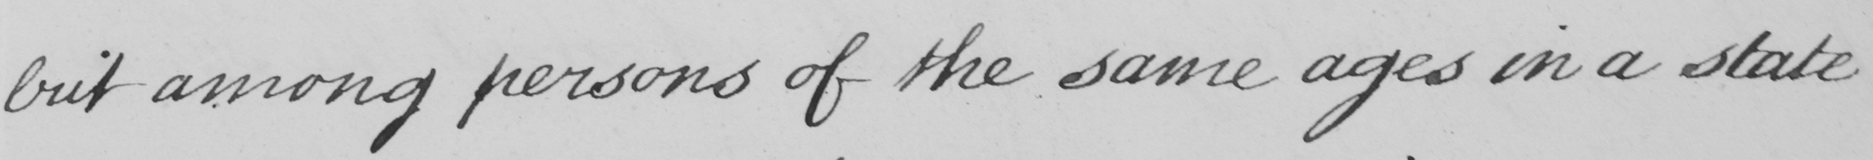What is written in this line of handwriting? but among persons of the same ages in a state 